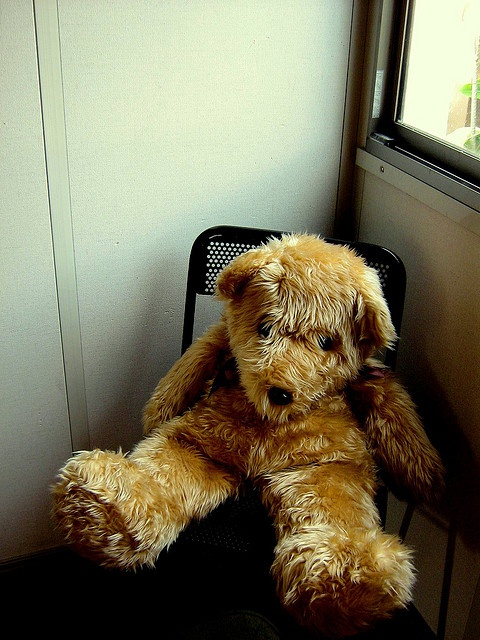Describe the objects in this image and their specific colors. I can see teddy bear in darkgray, black, maroon, and olive tones and chair in darkgray, black, gray, and olive tones in this image. 